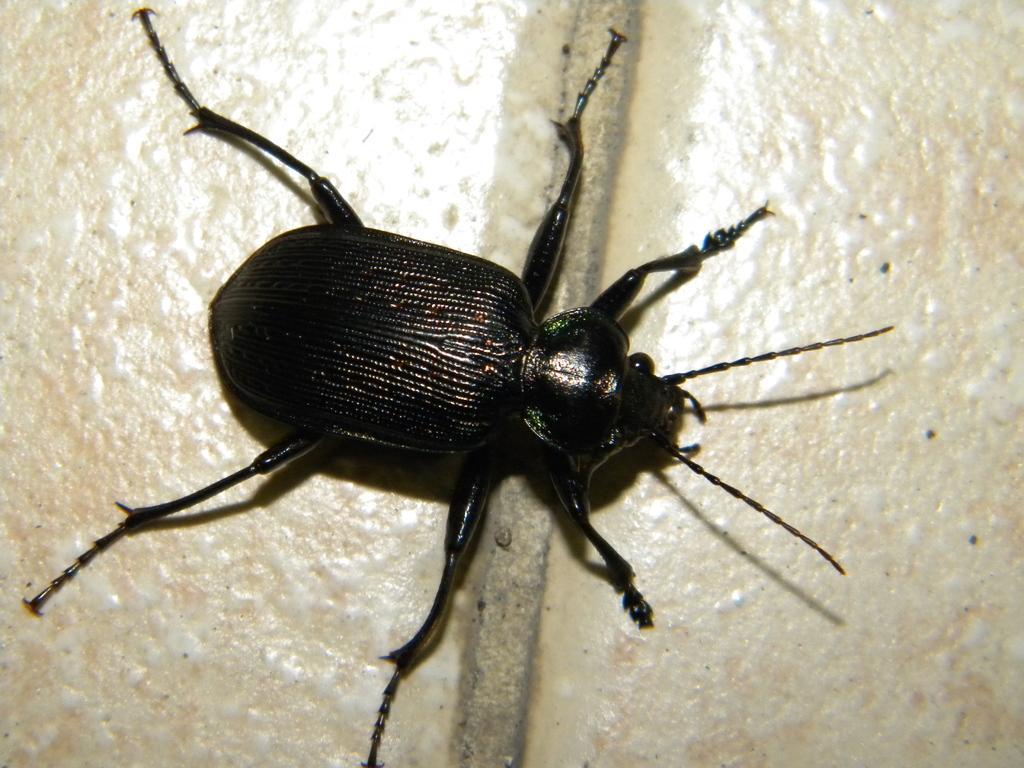In one or two sentences, can you explain what this image depicts? In this picture there is a black color insect on the tiles. 